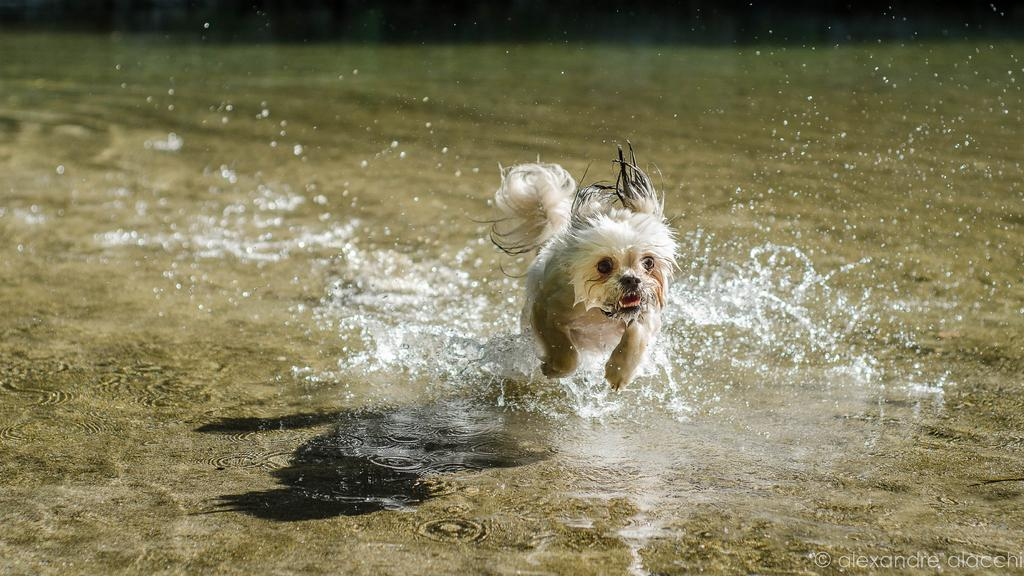What animal can be seen in the image? There is a dog in the image. What is the dog doing in the image? The dog is running in the water. Can you describe the background of the image? The background of the image is blurred. What type of skate is the dog wearing on its feet in the image? There is no skate present in the image; the dog is running in the water. What kind of coil can be seen in the dog's fur in the image? There is no coil present in the dog's fur in the image. 